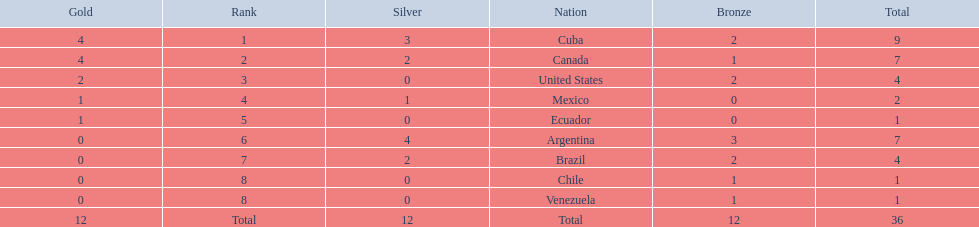Which countries have won gold medals? Cuba, Canada, United States, Mexico, Ecuador. Of these countries, which ones have never won silver or bronze medals? United States, Ecuador. Of the two nations listed previously, which one has only won a gold medal? Ecuador. 